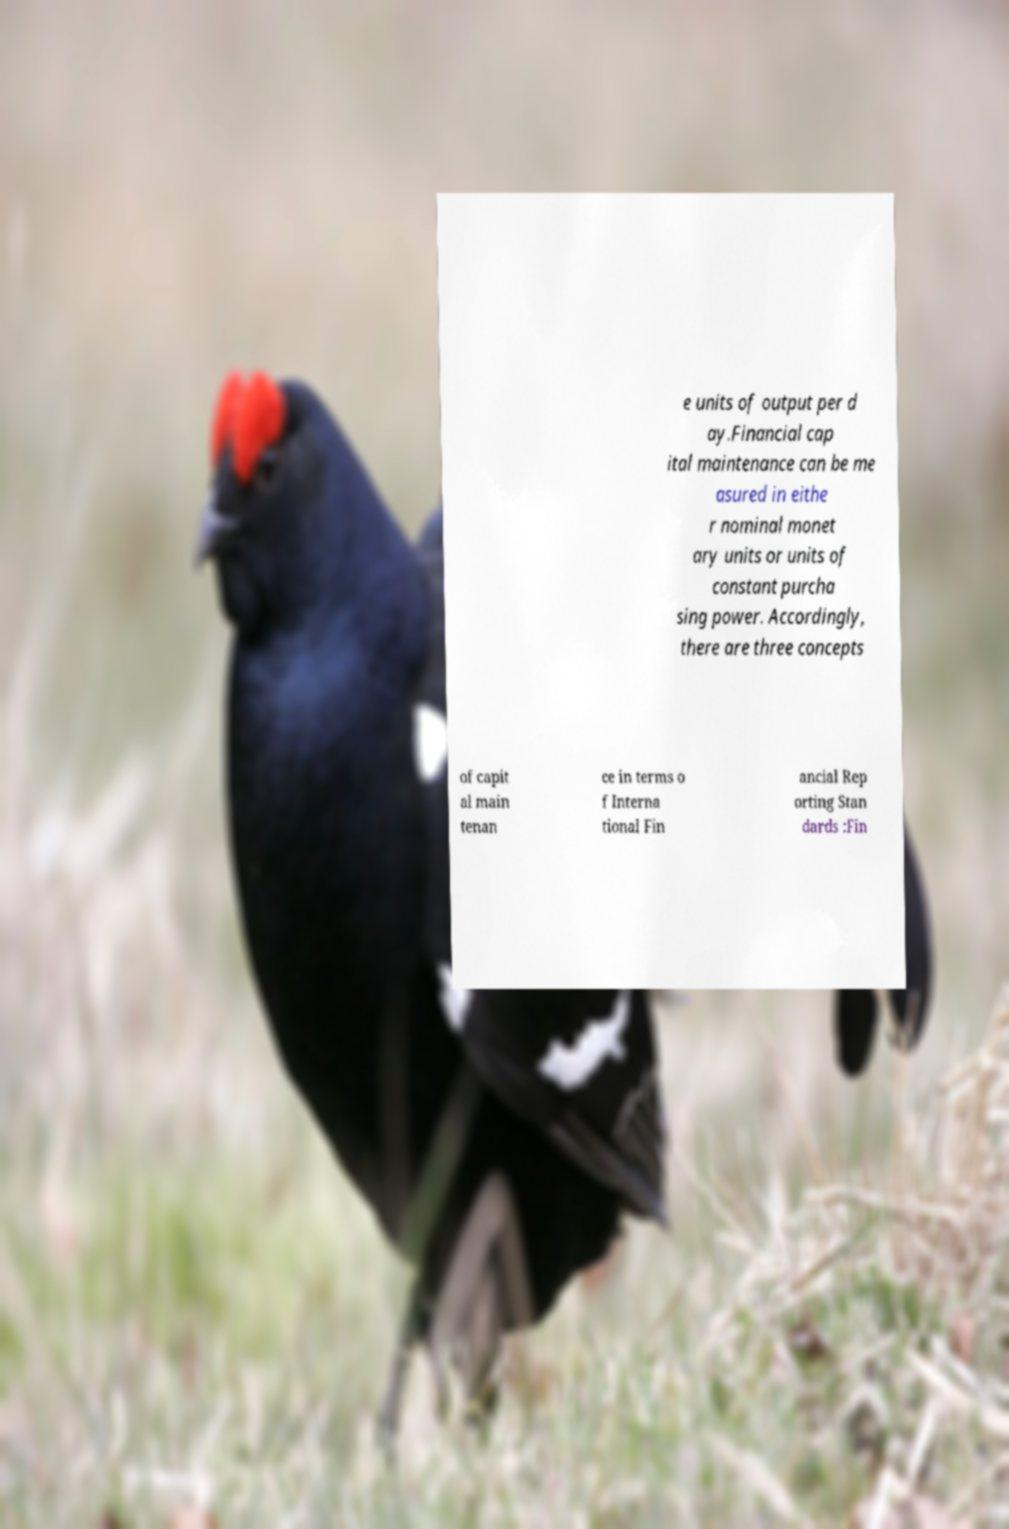There's text embedded in this image that I need extracted. Can you transcribe it verbatim? e units of output per d ay.Financial cap ital maintenance can be me asured in eithe r nominal monet ary units or units of constant purcha sing power. Accordingly, there are three concepts of capit al main tenan ce in terms o f Interna tional Fin ancial Rep orting Stan dards :Fin 